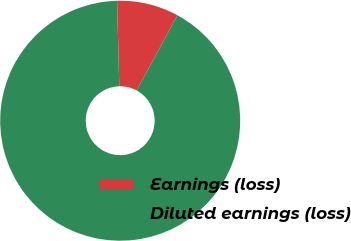Convert chart to OTSL. <chart><loc_0><loc_0><loc_500><loc_500><pie_chart><fcel>Earnings (loss)<fcel>Diluted earnings (loss)<nl><fcel>8.33%<fcel>91.67%<nl></chart> 